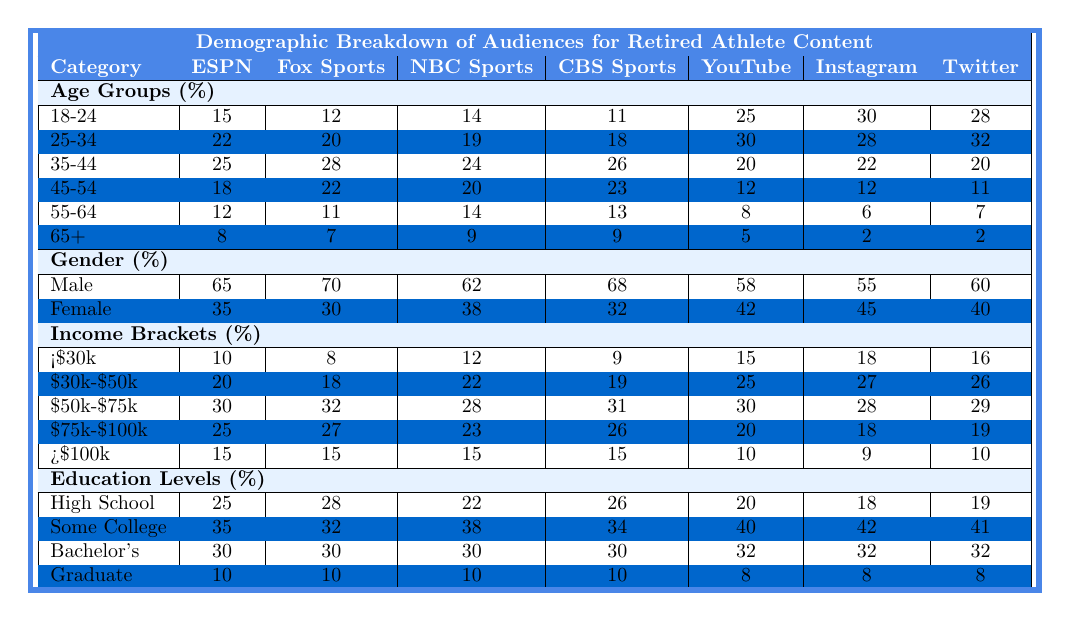What is the percentage of the 18-24 age group for ESPN? By looking at the ESPN column under the row for the 18-24 age group, we see the value is 15.
Answer: 15 Which platform has the highest percentage of the 25-34 age group? The percentages for the 25-34 age group are: ESPN 22, Fox Sports 20, NBC Sports 19, CBS Sports 18, YouTube 30, Instagram 28, Twitter 32. The highest value is from YouTube (30).
Answer: YouTube What percentage of the 65+ age group watches CBS Sports? Referring to the CBS Sports column under the 65+ age group, the value listed is 9.
Answer: 9 Which platform has the lowest female audience percentage? The female audience percentages are: ESPN 35, Fox Sports 30, NBC Sports 38, CBS Sports 32, YouTube 42, Instagram 45, Twitter 40. The lowest percentage is from Fox Sports (30).
Answer: Fox Sports What is the total percentage of the 55-64 age group across all platforms? Adding the values for 55-64 across all platforms gives us: ESPN 12 + Fox Sports 11 + NBC Sports 14 + CBS Sports 13 + YouTube 8 + Instagram 6 + Twitter 7 = 71.
Answer: 71 Is the percentage of high school graduates higher for ESPN or Twitter? ESPN has 25% and Twitter has 19%. Since 25 is greater than 19, the answer is yes, ESPN has a higher percentage of high school graduates.
Answer: Yes What is the average percentage of the income bracket "$30k-$50k" across all platforms? The percentages for this bracket are: ESPN 20, Fox Sports 18, NBC Sports 22, CBS Sports 19, YouTube 25, Instagram 27, Twitter 26. Adding these gives 20 + 18 + 22 + 19 + 25 + 27 + 26 =  157. Dividing by the number of platforms (7) gives an average of 22.43.
Answer: 22.43 Which income bracket has the highest percentage on YouTube? The percentages for the income brackets on YouTube are: <$30k 15, $30k-$50k 25, $50k-$75k 30, $75k-$100k 20, >$100k 10. The highest percentage is for the $50k-$75k bracket (30).
Answer: $50k-$75k Is it true that more than 60% of Twitter's demographic is female? The female percentage for Twitter is 40%, which is less than 60%, therefore the statement is false.
Answer: False What is the difference in percentage of some college graduates between Instagram and CBS Sports? The percentages for some college degree holders are: Instagram 42 and CBS Sports 34. Calculating the difference: 42 - 34 = 8.
Answer: 8 